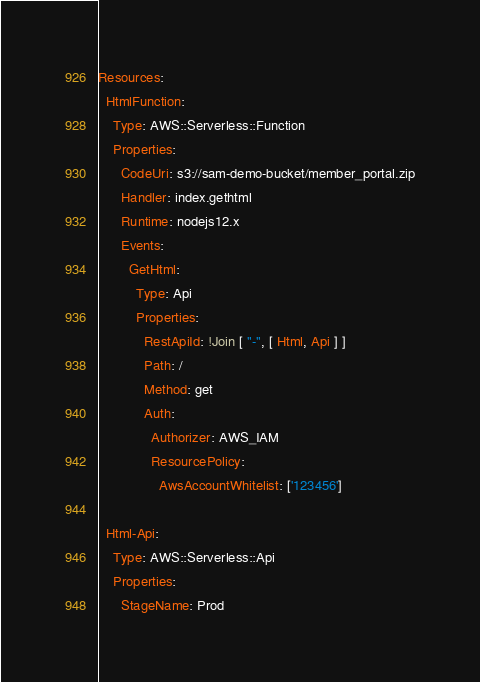<code> <loc_0><loc_0><loc_500><loc_500><_YAML_>Resources:
  HtmlFunction:
    Type: AWS::Serverless::Function
    Properties:
      CodeUri: s3://sam-demo-bucket/member_portal.zip
      Handler: index.gethtml
      Runtime: nodejs12.x
      Events:
        GetHtml:
          Type: Api
          Properties:
            RestApiId: !Join [ "-", [ Html, Api ] ]
            Path: /
            Method: get
            Auth:
              Authorizer: AWS_IAM
              ResourcePolicy:
                AwsAccountWhitelist: ['123456']

  Html-Api:
    Type: AWS::Serverless::Api
    Properties:
      StageName: Prod</code> 